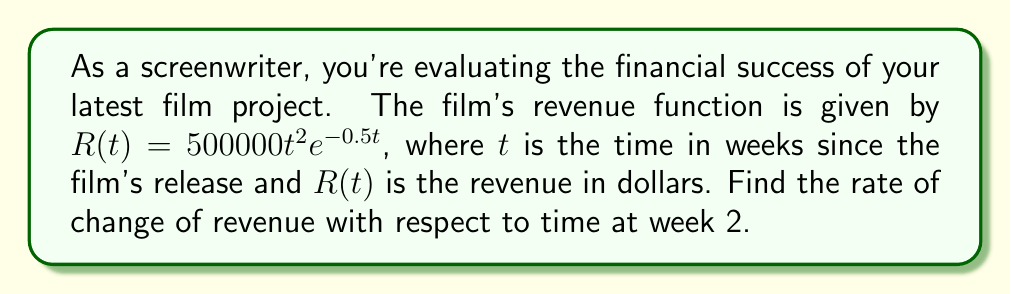What is the answer to this math problem? To find the rate of change of revenue with respect to time at week 2, we need to calculate the derivative of the revenue function $R(t)$ and evaluate it at $t=2$.

Step 1: Calculate the derivative of $R(t)$
Using the product rule and chain rule, we get:
$$\frac{dR}{dt} = (500000 \cdot 2t \cdot e^{-0.5t}) + (500000t^2 \cdot -0.5e^{-0.5t})$$

Step 2: Simplify the derivative
$$\frac{dR}{dt} = 1000000te^{-0.5t} - 250000t^2e^{-0.5t}$$
$$\frac{dR}{dt} = e^{-0.5t}(1000000t - 250000t^2)$$

Step 3: Evaluate the derivative at $t=2$
$$\frac{dR}{dt}\bigg|_{t=2} = e^{-0.5(2)}(1000000(2) - 250000(2)^2)$$
$$= e^{-1}(2000000 - 1000000)$$
$$= e^{-1}(1000000)$$
$$\approx 367879.44$$

Therefore, the rate of change of revenue with respect to time at week 2 is approximately $367,879.44 dollars per week.
Answer: $367879.44 dollars per week 